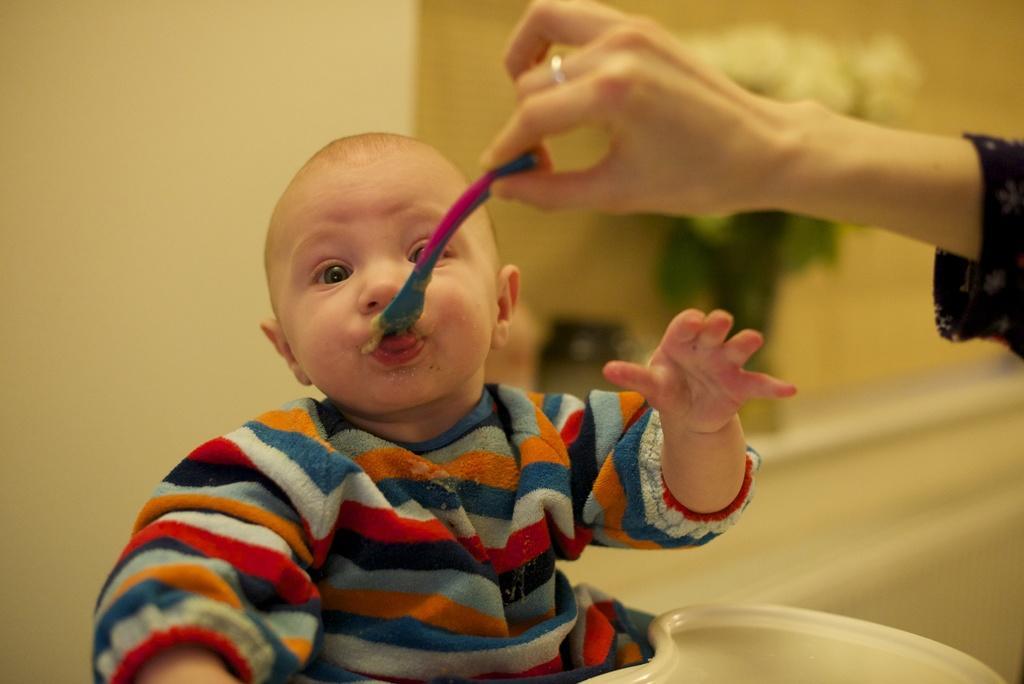How would you summarize this image in a sentence or two? In the image I can see a child is eating food. I can also see a spoon in a person's hand. In the background I can see a wall and some other objects. The background of the image is blurred. 